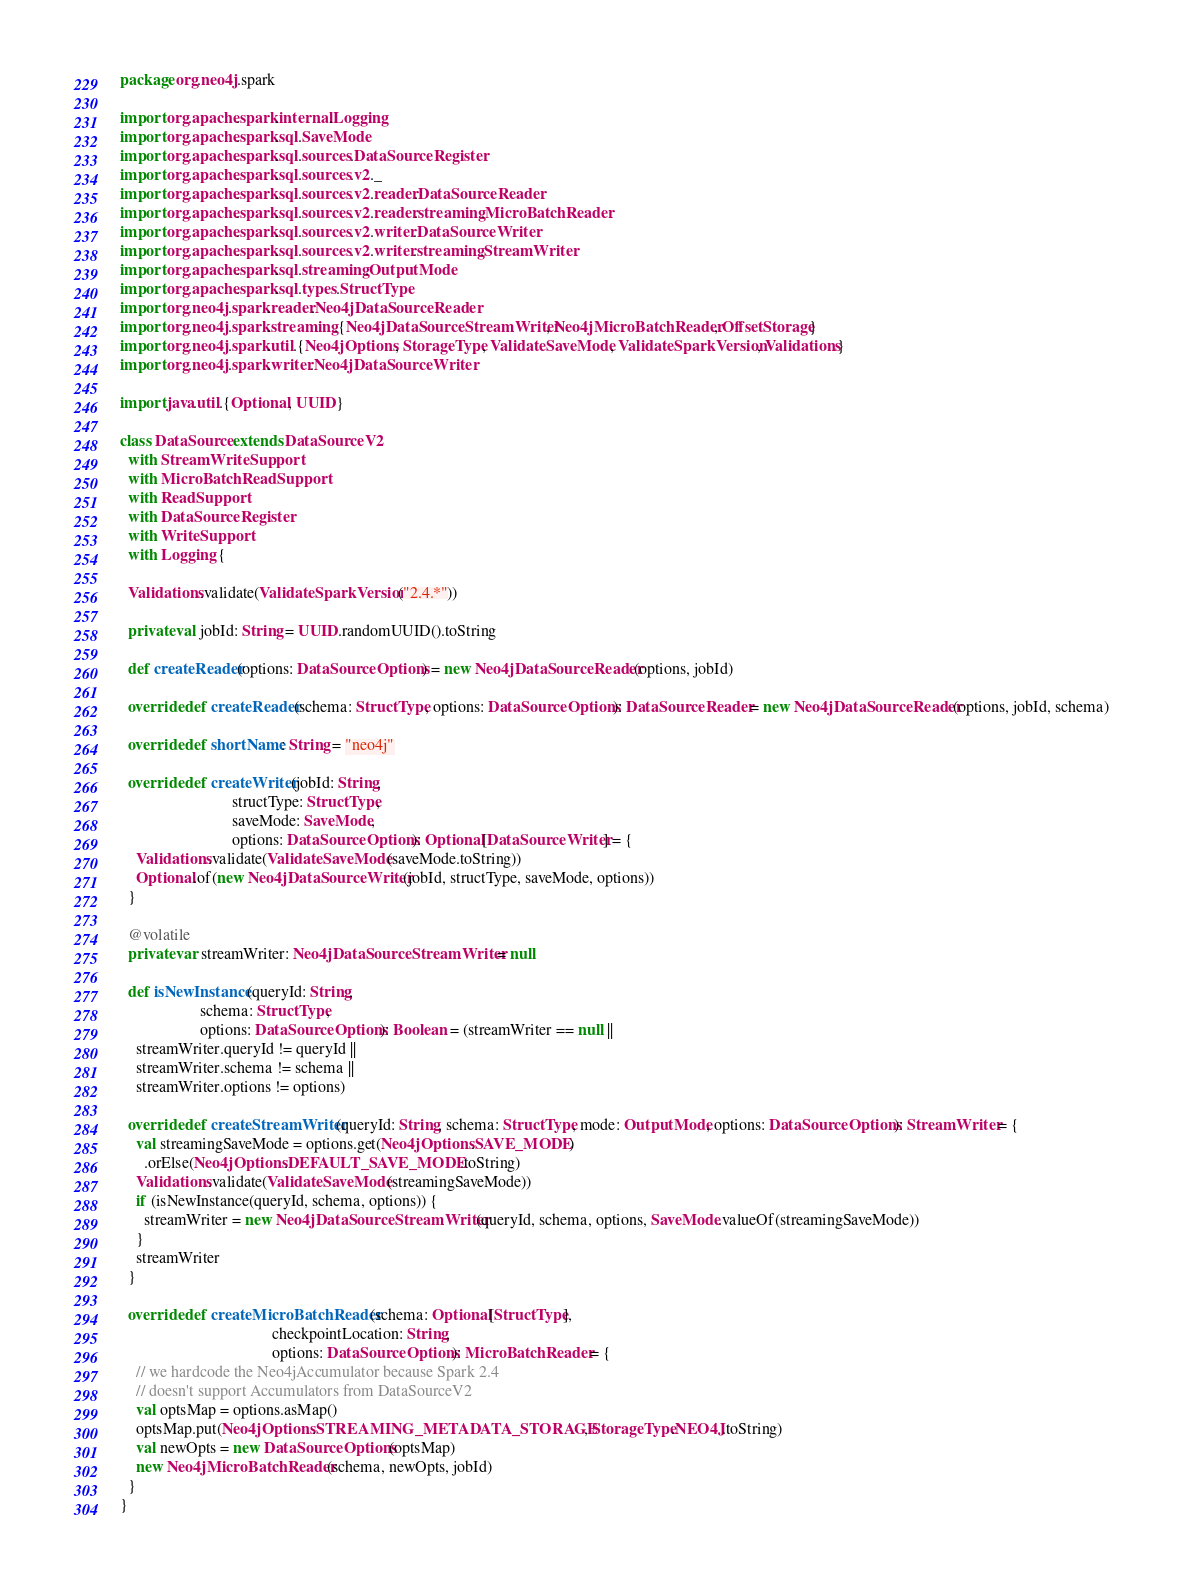<code> <loc_0><loc_0><loc_500><loc_500><_Scala_>package org.neo4j.spark

import org.apache.spark.internal.Logging
import org.apache.spark.sql.SaveMode
import org.apache.spark.sql.sources.DataSourceRegister
import org.apache.spark.sql.sources.v2._
import org.apache.spark.sql.sources.v2.reader.DataSourceReader
import org.apache.spark.sql.sources.v2.reader.streaming.MicroBatchReader
import org.apache.spark.sql.sources.v2.writer.DataSourceWriter
import org.apache.spark.sql.sources.v2.writer.streaming.StreamWriter
import org.apache.spark.sql.streaming.OutputMode
import org.apache.spark.sql.types.StructType
import org.neo4j.spark.reader.Neo4jDataSourceReader
import org.neo4j.spark.streaming.{Neo4jDataSourceStreamWriter, Neo4jMicroBatchReader, OffsetStorage}
import org.neo4j.spark.util.{Neo4jOptions, StorageType, ValidateSaveMode, ValidateSparkVersion, Validations}
import org.neo4j.spark.writer.Neo4jDataSourceWriter

import java.util.{Optional, UUID}

class DataSource extends DataSourceV2
  with StreamWriteSupport
  with MicroBatchReadSupport
  with ReadSupport
  with DataSourceRegister
  with WriteSupport
  with Logging {

  Validations.validate(ValidateSparkVersion("2.4.*"))

  private val jobId: String = UUID.randomUUID().toString

  def createReader(options: DataSourceOptions) = new Neo4jDataSourceReader(options, jobId)

  override def createReader(schema: StructType, options: DataSourceOptions): DataSourceReader = new Neo4jDataSourceReader(options, jobId, schema)

  override def shortName: String = "neo4j"

  override def createWriter(jobId: String,
                            structType: StructType,
                            saveMode: SaveMode,
                            options: DataSourceOptions): Optional[DataSourceWriter] = {
    Validations.validate(ValidateSaveMode(saveMode.toString))
    Optional.of(new Neo4jDataSourceWriter(jobId, structType, saveMode, options))
  }

  @volatile
  private var streamWriter: Neo4jDataSourceStreamWriter = null

  def isNewInstance(queryId: String,
                    schema: StructType,
                    options: DataSourceOptions): Boolean = (streamWriter == null ||
    streamWriter.queryId != queryId ||
    streamWriter.schema != schema ||
    streamWriter.options != options)

  override def createStreamWriter(queryId: String, schema: StructType, mode: OutputMode, options: DataSourceOptions): StreamWriter = {
    val streamingSaveMode = options.get(Neo4jOptions.SAVE_MODE)
      .orElse(Neo4jOptions.DEFAULT_SAVE_MODE.toString)
    Validations.validate(ValidateSaveMode(streamingSaveMode))
    if (isNewInstance(queryId, schema, options)) {
      streamWriter = new Neo4jDataSourceStreamWriter(queryId, schema, options, SaveMode.valueOf(streamingSaveMode))
    }
    streamWriter
  }

  override def createMicroBatchReader(schema: Optional[StructType],
                                      checkpointLocation: String,
                                      options: DataSourceOptions): MicroBatchReader = {
    // we hardcode the Neo4jAccumulator because Spark 2.4
    // doesn't support Accumulators from DataSourceV2
    val optsMap = options.asMap()
    optsMap.put(Neo4jOptions.STREAMING_METADATA_STORAGE, StorageType.NEO4J.toString)
    val newOpts = new DataSourceOptions(optsMap)
    new Neo4jMicroBatchReader(schema, newOpts, jobId)
  }
}</code> 